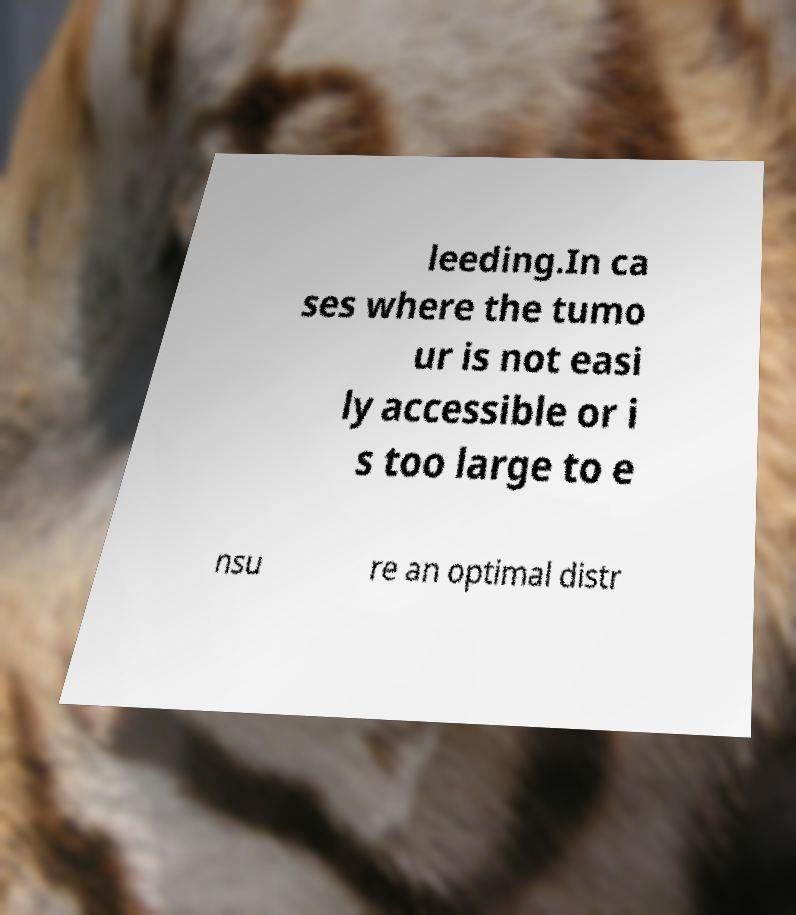There's text embedded in this image that I need extracted. Can you transcribe it verbatim? leeding.In ca ses where the tumo ur is not easi ly accessible or i s too large to e nsu re an optimal distr 